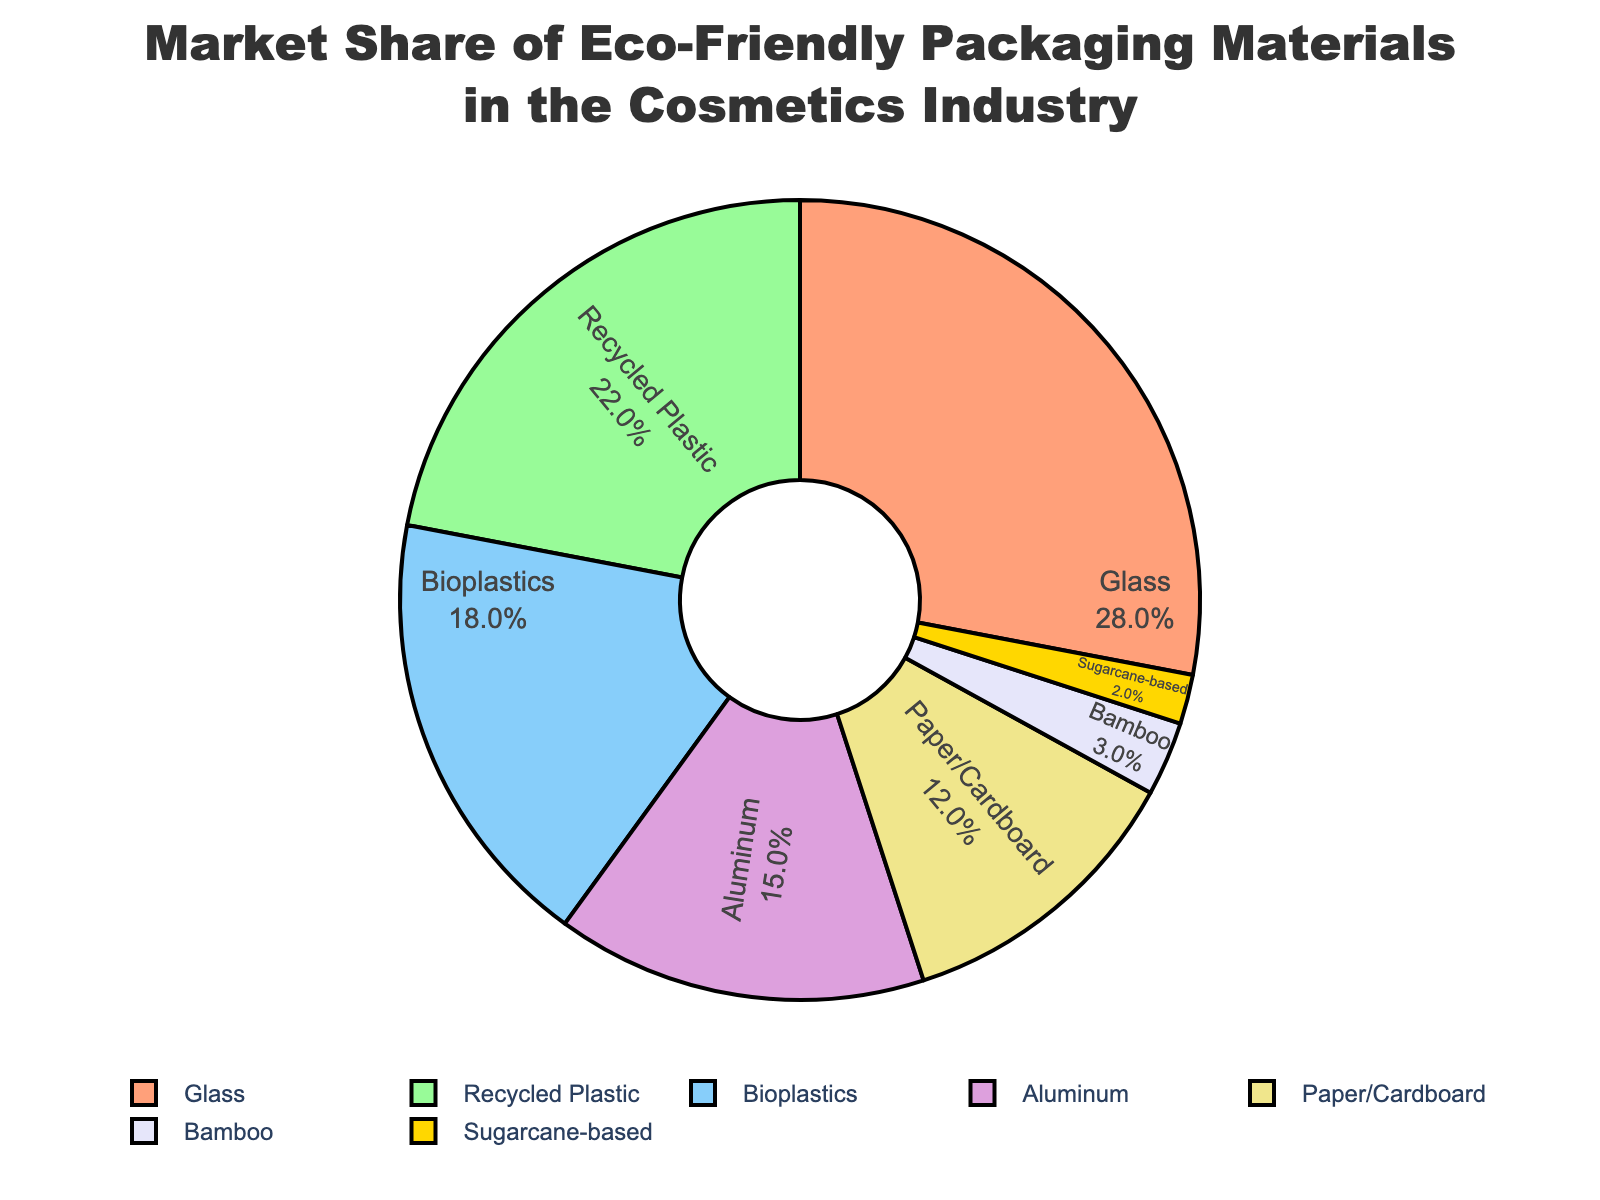What material has the largest market share? By observing the pie chart, the largest segment is visually identifiable as the largest slice, labeled "Glass" with a share of 28%.
Answer: Glass What is the combined market share of Bioplastics and Paper/Cardboard? The market shares of Bioplastics and Paper/Cardboard are 18% and 12% respectively. Adding these together, 18 + 12 = 30%.
Answer: 30% Which material has a market share just below 20%? By looking at the percentages labeled in the pie chart, the material with a market share just below 20% is Bioplastics at 18%.
Answer: Bioplastics Compare the market share of Aluminum and Bamboo. Which one is higher and by how much? Aluminum's market share is 15%, while Bamboo's is 3%. Subtracting these values gives 15 - 3 = 12%. Hence, Aluminum's market share is higher by 12%.
Answer: Aluminum, by 12% What is the percentage difference between the market share of Recycled Plastic and Sugarcane-based materials? The market share for Recycled Plastic is 22% while for Sugarcane-based materials it is 2%. The difference is calculated as 22 - 2 = 20%.
Answer: 20% What proportion of the market share is held by materials other than Glass? The total market share held by all materials is 100%. Subtracting the market share of Glass (28%), we get 100 - 28 = 72%.
Answer: 72% How does the market share of Paper/Cardboard compare to that of Sugarcane-based materials, visually represented? Paper/Cardboard has a significantly larger slice in the pie chart compared to Sugarcane-based materials. The values are 12% for Paper/Cardboard and 2% for Sugarcane-based. This indicates Paper/Cardboard's share is 6 times that of Sugarcane-based materials.
Answer: Paper/Cardboard, significantly larger If the shares of Recycled Plastic and Glass are combined, how does their total compare to the total share of all other materials? The market shares for Recycled Plastic and Glass are 22% and 28% respectively, amounting to a combined share of 22 + 28 = 50%. Thus, 50% of the market is held by these two materials. Subtracting this from the total 100%, we get 100 - 50 = 50%, showing that the remaining materials also account for 50%.
Answer: Equal Which material has a market share colored in blue? The blue color is visually recognizable on the pie chart and corresponds to Bioplastics, which has an 18% market share.
Answer: Bioplastics Is the market share of any single material larger than the combined share of Paper/Cardboard, Bamboo, and Sugarcane-based? Glass has a 28% share. Combining the shares of Paper/Cardboard (12%), Bamboo (3%), and Sugarcane-based (2%) gives 12 + 3 + 2 = 17%, which is less than 28%. Thus, the market share of Glass is larger.
Answer: Yes 